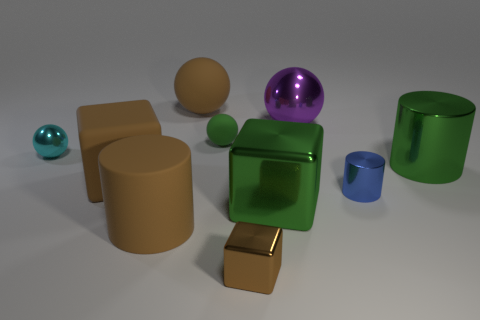Subtract all blocks. How many objects are left? 7 Add 9 big brown cylinders. How many big brown cylinders exist? 10 Subtract 0 blue blocks. How many objects are left? 10 Subtract all big brown rubber cubes. Subtract all large red cylinders. How many objects are left? 9 Add 6 small green spheres. How many small green spheres are left? 7 